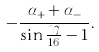Convert formula to latex. <formula><loc_0><loc_0><loc_500><loc_500>- \frac { \alpha _ { + } + \alpha _ { - } } { \sin { \frac { n \gamma } { 1 6 } } - 1 } .</formula> 